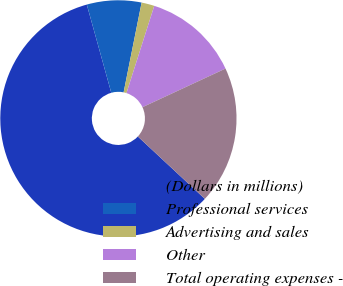Convert chart. <chart><loc_0><loc_0><loc_500><loc_500><pie_chart><fcel>(Dollars in millions)<fcel>Professional services<fcel>Advertising and sales<fcel>Other<fcel>Total operating expenses -<nl><fcel>58.75%<fcel>7.46%<fcel>1.76%<fcel>13.16%<fcel>18.86%<nl></chart> 